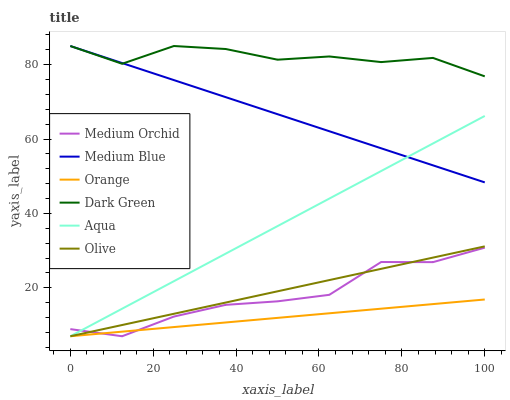Does Orange have the minimum area under the curve?
Answer yes or no. Yes. Does Dark Green have the maximum area under the curve?
Answer yes or no. Yes. Does Medium Orchid have the minimum area under the curve?
Answer yes or no. No. Does Medium Orchid have the maximum area under the curve?
Answer yes or no. No. Is Orange the smoothest?
Answer yes or no. Yes. Is Medium Orchid the roughest?
Answer yes or no. Yes. Is Aqua the smoothest?
Answer yes or no. No. Is Aqua the roughest?
Answer yes or no. No. Does Dark Green have the lowest value?
Answer yes or no. No. Does Medium Orchid have the highest value?
Answer yes or no. No. Is Aqua less than Dark Green?
Answer yes or no. Yes. Is Dark Green greater than Aqua?
Answer yes or no. Yes. Does Aqua intersect Dark Green?
Answer yes or no. No. 